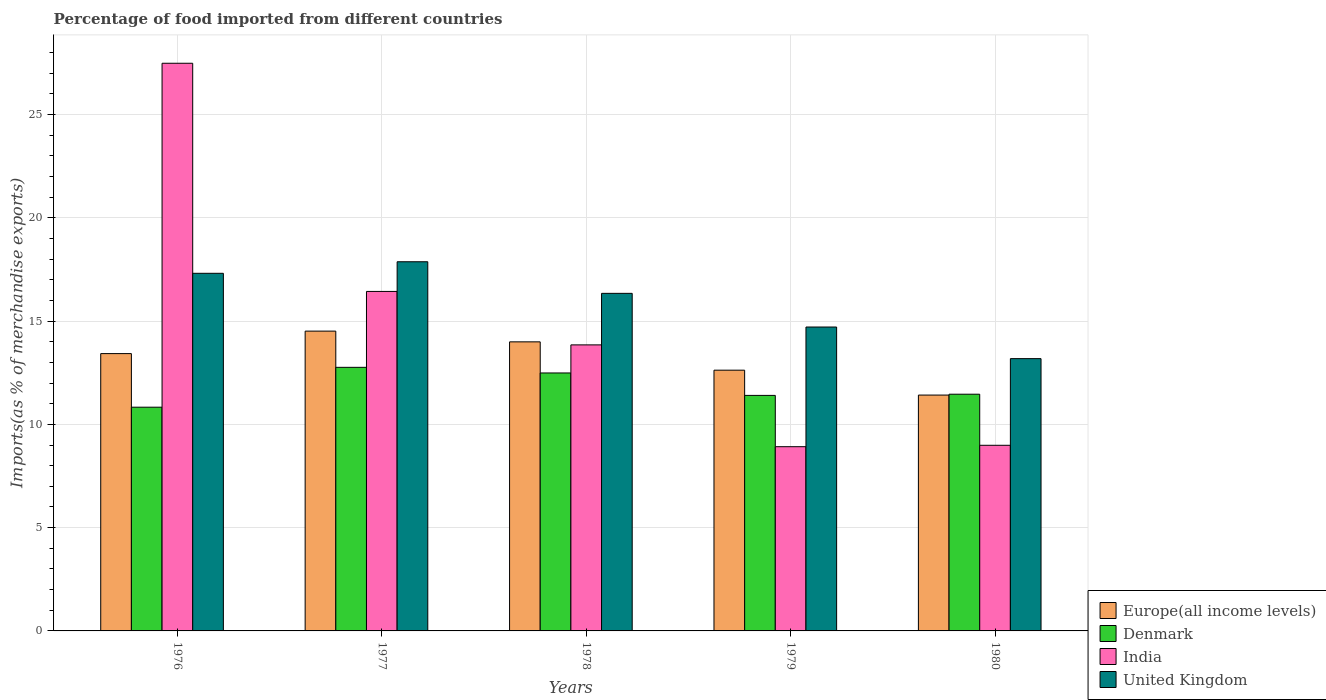How many groups of bars are there?
Provide a short and direct response. 5. Are the number of bars per tick equal to the number of legend labels?
Your answer should be very brief. Yes. How many bars are there on the 5th tick from the left?
Your answer should be compact. 4. How many bars are there on the 2nd tick from the right?
Give a very brief answer. 4. What is the label of the 2nd group of bars from the left?
Give a very brief answer. 1977. In how many cases, is the number of bars for a given year not equal to the number of legend labels?
Make the answer very short. 0. What is the percentage of imports to different countries in Denmark in 1978?
Provide a short and direct response. 12.49. Across all years, what is the maximum percentage of imports to different countries in Europe(all income levels)?
Your answer should be very brief. 14.51. Across all years, what is the minimum percentage of imports to different countries in Denmark?
Ensure brevity in your answer.  10.83. In which year was the percentage of imports to different countries in India maximum?
Give a very brief answer. 1976. What is the total percentage of imports to different countries in Europe(all income levels) in the graph?
Your response must be concise. 65.97. What is the difference between the percentage of imports to different countries in India in 1976 and that in 1978?
Your response must be concise. 13.63. What is the difference between the percentage of imports to different countries in Denmark in 1977 and the percentage of imports to different countries in United Kingdom in 1978?
Your answer should be compact. -3.58. What is the average percentage of imports to different countries in Denmark per year?
Ensure brevity in your answer.  11.79. In the year 1980, what is the difference between the percentage of imports to different countries in United Kingdom and percentage of imports to different countries in Europe(all income levels)?
Your answer should be very brief. 1.76. In how many years, is the percentage of imports to different countries in India greater than 10 %?
Your response must be concise. 3. What is the ratio of the percentage of imports to different countries in Europe(all income levels) in 1978 to that in 1979?
Your answer should be very brief. 1.11. Is the percentage of imports to different countries in Denmark in 1978 less than that in 1980?
Provide a short and direct response. No. What is the difference between the highest and the second highest percentage of imports to different countries in Denmark?
Give a very brief answer. 0.27. What is the difference between the highest and the lowest percentage of imports to different countries in Denmark?
Offer a very short reply. 1.93. In how many years, is the percentage of imports to different countries in Europe(all income levels) greater than the average percentage of imports to different countries in Europe(all income levels) taken over all years?
Provide a short and direct response. 3. Is the sum of the percentage of imports to different countries in Europe(all income levels) in 1977 and 1980 greater than the maximum percentage of imports to different countries in India across all years?
Offer a terse response. No. What does the 2nd bar from the right in 1978 represents?
Give a very brief answer. India. Is it the case that in every year, the sum of the percentage of imports to different countries in India and percentage of imports to different countries in Europe(all income levels) is greater than the percentage of imports to different countries in United Kingdom?
Your answer should be very brief. Yes. How many bars are there?
Ensure brevity in your answer.  20. Are all the bars in the graph horizontal?
Ensure brevity in your answer.  No. How many years are there in the graph?
Offer a very short reply. 5. Does the graph contain any zero values?
Provide a short and direct response. No. Does the graph contain grids?
Provide a succinct answer. Yes. Where does the legend appear in the graph?
Offer a terse response. Bottom right. How are the legend labels stacked?
Your response must be concise. Vertical. What is the title of the graph?
Provide a succinct answer. Percentage of food imported from different countries. What is the label or title of the Y-axis?
Offer a very short reply. Imports(as % of merchandise exports). What is the Imports(as % of merchandise exports) in Europe(all income levels) in 1976?
Your answer should be compact. 13.42. What is the Imports(as % of merchandise exports) in Denmark in 1976?
Ensure brevity in your answer.  10.83. What is the Imports(as % of merchandise exports) of India in 1976?
Provide a succinct answer. 27.48. What is the Imports(as % of merchandise exports) in United Kingdom in 1976?
Your answer should be very brief. 17.31. What is the Imports(as % of merchandise exports) in Europe(all income levels) in 1977?
Ensure brevity in your answer.  14.51. What is the Imports(as % of merchandise exports) in Denmark in 1977?
Provide a short and direct response. 12.76. What is the Imports(as % of merchandise exports) in India in 1977?
Make the answer very short. 16.43. What is the Imports(as % of merchandise exports) of United Kingdom in 1977?
Your response must be concise. 17.87. What is the Imports(as % of merchandise exports) in Europe(all income levels) in 1978?
Offer a terse response. 13.99. What is the Imports(as % of merchandise exports) of Denmark in 1978?
Your response must be concise. 12.49. What is the Imports(as % of merchandise exports) of India in 1978?
Your response must be concise. 13.85. What is the Imports(as % of merchandise exports) of United Kingdom in 1978?
Your answer should be very brief. 16.34. What is the Imports(as % of merchandise exports) in Europe(all income levels) in 1979?
Provide a succinct answer. 12.62. What is the Imports(as % of merchandise exports) of Denmark in 1979?
Your answer should be compact. 11.4. What is the Imports(as % of merchandise exports) in India in 1979?
Offer a very short reply. 8.92. What is the Imports(as % of merchandise exports) of United Kingdom in 1979?
Offer a terse response. 14.71. What is the Imports(as % of merchandise exports) of Europe(all income levels) in 1980?
Offer a terse response. 11.42. What is the Imports(as % of merchandise exports) in Denmark in 1980?
Offer a very short reply. 11.46. What is the Imports(as % of merchandise exports) of India in 1980?
Ensure brevity in your answer.  8.99. What is the Imports(as % of merchandise exports) of United Kingdom in 1980?
Keep it short and to the point. 13.18. Across all years, what is the maximum Imports(as % of merchandise exports) in Europe(all income levels)?
Keep it short and to the point. 14.51. Across all years, what is the maximum Imports(as % of merchandise exports) in Denmark?
Provide a succinct answer. 12.76. Across all years, what is the maximum Imports(as % of merchandise exports) of India?
Your answer should be compact. 27.48. Across all years, what is the maximum Imports(as % of merchandise exports) of United Kingdom?
Provide a short and direct response. 17.87. Across all years, what is the minimum Imports(as % of merchandise exports) of Europe(all income levels)?
Provide a short and direct response. 11.42. Across all years, what is the minimum Imports(as % of merchandise exports) in Denmark?
Offer a very short reply. 10.83. Across all years, what is the minimum Imports(as % of merchandise exports) of India?
Provide a succinct answer. 8.92. Across all years, what is the minimum Imports(as % of merchandise exports) in United Kingdom?
Make the answer very short. 13.18. What is the total Imports(as % of merchandise exports) in Europe(all income levels) in the graph?
Provide a succinct answer. 65.97. What is the total Imports(as % of merchandise exports) in Denmark in the graph?
Your response must be concise. 58.94. What is the total Imports(as % of merchandise exports) in India in the graph?
Keep it short and to the point. 75.67. What is the total Imports(as % of merchandise exports) in United Kingdom in the graph?
Your answer should be compact. 79.42. What is the difference between the Imports(as % of merchandise exports) in Europe(all income levels) in 1976 and that in 1977?
Offer a terse response. -1.09. What is the difference between the Imports(as % of merchandise exports) in Denmark in 1976 and that in 1977?
Offer a terse response. -1.93. What is the difference between the Imports(as % of merchandise exports) in India in 1976 and that in 1977?
Offer a terse response. 11.05. What is the difference between the Imports(as % of merchandise exports) of United Kingdom in 1976 and that in 1977?
Provide a succinct answer. -0.56. What is the difference between the Imports(as % of merchandise exports) of Europe(all income levels) in 1976 and that in 1978?
Your response must be concise. -0.57. What is the difference between the Imports(as % of merchandise exports) in Denmark in 1976 and that in 1978?
Keep it short and to the point. -1.66. What is the difference between the Imports(as % of merchandise exports) of India in 1976 and that in 1978?
Give a very brief answer. 13.63. What is the difference between the Imports(as % of merchandise exports) of United Kingdom in 1976 and that in 1978?
Keep it short and to the point. 0.97. What is the difference between the Imports(as % of merchandise exports) in Europe(all income levels) in 1976 and that in 1979?
Your answer should be very brief. 0.8. What is the difference between the Imports(as % of merchandise exports) of Denmark in 1976 and that in 1979?
Provide a short and direct response. -0.57. What is the difference between the Imports(as % of merchandise exports) in India in 1976 and that in 1979?
Offer a very short reply. 18.56. What is the difference between the Imports(as % of merchandise exports) of United Kingdom in 1976 and that in 1979?
Your answer should be compact. 2.6. What is the difference between the Imports(as % of merchandise exports) of Europe(all income levels) in 1976 and that in 1980?
Make the answer very short. 2.01. What is the difference between the Imports(as % of merchandise exports) in Denmark in 1976 and that in 1980?
Provide a short and direct response. -0.63. What is the difference between the Imports(as % of merchandise exports) of India in 1976 and that in 1980?
Give a very brief answer. 18.49. What is the difference between the Imports(as % of merchandise exports) of United Kingdom in 1976 and that in 1980?
Your answer should be compact. 4.13. What is the difference between the Imports(as % of merchandise exports) of Europe(all income levels) in 1977 and that in 1978?
Keep it short and to the point. 0.52. What is the difference between the Imports(as % of merchandise exports) of Denmark in 1977 and that in 1978?
Offer a terse response. 0.27. What is the difference between the Imports(as % of merchandise exports) in India in 1977 and that in 1978?
Offer a terse response. 2.59. What is the difference between the Imports(as % of merchandise exports) in United Kingdom in 1977 and that in 1978?
Provide a short and direct response. 1.53. What is the difference between the Imports(as % of merchandise exports) in Europe(all income levels) in 1977 and that in 1979?
Your answer should be very brief. 1.89. What is the difference between the Imports(as % of merchandise exports) in Denmark in 1977 and that in 1979?
Make the answer very short. 1.36. What is the difference between the Imports(as % of merchandise exports) in India in 1977 and that in 1979?
Your answer should be compact. 7.52. What is the difference between the Imports(as % of merchandise exports) in United Kingdom in 1977 and that in 1979?
Make the answer very short. 3.16. What is the difference between the Imports(as % of merchandise exports) in Europe(all income levels) in 1977 and that in 1980?
Make the answer very short. 3.1. What is the difference between the Imports(as % of merchandise exports) of Denmark in 1977 and that in 1980?
Provide a succinct answer. 1.3. What is the difference between the Imports(as % of merchandise exports) of India in 1977 and that in 1980?
Keep it short and to the point. 7.45. What is the difference between the Imports(as % of merchandise exports) of United Kingdom in 1977 and that in 1980?
Your response must be concise. 4.69. What is the difference between the Imports(as % of merchandise exports) of Europe(all income levels) in 1978 and that in 1979?
Provide a short and direct response. 1.37. What is the difference between the Imports(as % of merchandise exports) in Denmark in 1978 and that in 1979?
Keep it short and to the point. 1.09. What is the difference between the Imports(as % of merchandise exports) of India in 1978 and that in 1979?
Provide a short and direct response. 4.93. What is the difference between the Imports(as % of merchandise exports) in United Kingdom in 1978 and that in 1979?
Make the answer very short. 1.63. What is the difference between the Imports(as % of merchandise exports) in Europe(all income levels) in 1978 and that in 1980?
Provide a succinct answer. 2.58. What is the difference between the Imports(as % of merchandise exports) in Denmark in 1978 and that in 1980?
Offer a terse response. 1.03. What is the difference between the Imports(as % of merchandise exports) in India in 1978 and that in 1980?
Offer a very short reply. 4.86. What is the difference between the Imports(as % of merchandise exports) in United Kingdom in 1978 and that in 1980?
Provide a short and direct response. 3.16. What is the difference between the Imports(as % of merchandise exports) of Europe(all income levels) in 1979 and that in 1980?
Make the answer very short. 1.21. What is the difference between the Imports(as % of merchandise exports) of Denmark in 1979 and that in 1980?
Your response must be concise. -0.06. What is the difference between the Imports(as % of merchandise exports) in India in 1979 and that in 1980?
Give a very brief answer. -0.07. What is the difference between the Imports(as % of merchandise exports) of United Kingdom in 1979 and that in 1980?
Provide a succinct answer. 1.53. What is the difference between the Imports(as % of merchandise exports) of Europe(all income levels) in 1976 and the Imports(as % of merchandise exports) of Denmark in 1977?
Your response must be concise. 0.66. What is the difference between the Imports(as % of merchandise exports) of Europe(all income levels) in 1976 and the Imports(as % of merchandise exports) of India in 1977?
Give a very brief answer. -3.01. What is the difference between the Imports(as % of merchandise exports) of Europe(all income levels) in 1976 and the Imports(as % of merchandise exports) of United Kingdom in 1977?
Make the answer very short. -4.45. What is the difference between the Imports(as % of merchandise exports) in Denmark in 1976 and the Imports(as % of merchandise exports) in India in 1977?
Provide a short and direct response. -5.6. What is the difference between the Imports(as % of merchandise exports) of Denmark in 1976 and the Imports(as % of merchandise exports) of United Kingdom in 1977?
Ensure brevity in your answer.  -7.04. What is the difference between the Imports(as % of merchandise exports) of India in 1976 and the Imports(as % of merchandise exports) of United Kingdom in 1977?
Make the answer very short. 9.61. What is the difference between the Imports(as % of merchandise exports) in Europe(all income levels) in 1976 and the Imports(as % of merchandise exports) in Denmark in 1978?
Provide a succinct answer. 0.94. What is the difference between the Imports(as % of merchandise exports) in Europe(all income levels) in 1976 and the Imports(as % of merchandise exports) in India in 1978?
Offer a terse response. -0.42. What is the difference between the Imports(as % of merchandise exports) in Europe(all income levels) in 1976 and the Imports(as % of merchandise exports) in United Kingdom in 1978?
Give a very brief answer. -2.92. What is the difference between the Imports(as % of merchandise exports) in Denmark in 1976 and the Imports(as % of merchandise exports) in India in 1978?
Make the answer very short. -3.02. What is the difference between the Imports(as % of merchandise exports) in Denmark in 1976 and the Imports(as % of merchandise exports) in United Kingdom in 1978?
Offer a terse response. -5.51. What is the difference between the Imports(as % of merchandise exports) in India in 1976 and the Imports(as % of merchandise exports) in United Kingdom in 1978?
Ensure brevity in your answer.  11.14. What is the difference between the Imports(as % of merchandise exports) in Europe(all income levels) in 1976 and the Imports(as % of merchandise exports) in Denmark in 1979?
Give a very brief answer. 2.02. What is the difference between the Imports(as % of merchandise exports) of Europe(all income levels) in 1976 and the Imports(as % of merchandise exports) of India in 1979?
Your answer should be compact. 4.51. What is the difference between the Imports(as % of merchandise exports) of Europe(all income levels) in 1976 and the Imports(as % of merchandise exports) of United Kingdom in 1979?
Offer a very short reply. -1.29. What is the difference between the Imports(as % of merchandise exports) of Denmark in 1976 and the Imports(as % of merchandise exports) of India in 1979?
Your answer should be compact. 1.91. What is the difference between the Imports(as % of merchandise exports) of Denmark in 1976 and the Imports(as % of merchandise exports) of United Kingdom in 1979?
Keep it short and to the point. -3.88. What is the difference between the Imports(as % of merchandise exports) of India in 1976 and the Imports(as % of merchandise exports) of United Kingdom in 1979?
Ensure brevity in your answer.  12.77. What is the difference between the Imports(as % of merchandise exports) in Europe(all income levels) in 1976 and the Imports(as % of merchandise exports) in Denmark in 1980?
Your response must be concise. 1.97. What is the difference between the Imports(as % of merchandise exports) of Europe(all income levels) in 1976 and the Imports(as % of merchandise exports) of India in 1980?
Offer a very short reply. 4.44. What is the difference between the Imports(as % of merchandise exports) of Europe(all income levels) in 1976 and the Imports(as % of merchandise exports) of United Kingdom in 1980?
Offer a very short reply. 0.24. What is the difference between the Imports(as % of merchandise exports) of Denmark in 1976 and the Imports(as % of merchandise exports) of India in 1980?
Your response must be concise. 1.84. What is the difference between the Imports(as % of merchandise exports) of Denmark in 1976 and the Imports(as % of merchandise exports) of United Kingdom in 1980?
Your answer should be very brief. -2.35. What is the difference between the Imports(as % of merchandise exports) of India in 1976 and the Imports(as % of merchandise exports) of United Kingdom in 1980?
Offer a very short reply. 14.3. What is the difference between the Imports(as % of merchandise exports) of Europe(all income levels) in 1977 and the Imports(as % of merchandise exports) of Denmark in 1978?
Ensure brevity in your answer.  2.03. What is the difference between the Imports(as % of merchandise exports) in Europe(all income levels) in 1977 and the Imports(as % of merchandise exports) in India in 1978?
Provide a succinct answer. 0.67. What is the difference between the Imports(as % of merchandise exports) in Europe(all income levels) in 1977 and the Imports(as % of merchandise exports) in United Kingdom in 1978?
Your response must be concise. -1.83. What is the difference between the Imports(as % of merchandise exports) in Denmark in 1977 and the Imports(as % of merchandise exports) in India in 1978?
Provide a succinct answer. -1.09. What is the difference between the Imports(as % of merchandise exports) of Denmark in 1977 and the Imports(as % of merchandise exports) of United Kingdom in 1978?
Provide a short and direct response. -3.58. What is the difference between the Imports(as % of merchandise exports) in India in 1977 and the Imports(as % of merchandise exports) in United Kingdom in 1978?
Ensure brevity in your answer.  0.09. What is the difference between the Imports(as % of merchandise exports) in Europe(all income levels) in 1977 and the Imports(as % of merchandise exports) in Denmark in 1979?
Your response must be concise. 3.11. What is the difference between the Imports(as % of merchandise exports) in Europe(all income levels) in 1977 and the Imports(as % of merchandise exports) in India in 1979?
Make the answer very short. 5.59. What is the difference between the Imports(as % of merchandise exports) of Europe(all income levels) in 1977 and the Imports(as % of merchandise exports) of United Kingdom in 1979?
Your response must be concise. -0.2. What is the difference between the Imports(as % of merchandise exports) of Denmark in 1977 and the Imports(as % of merchandise exports) of India in 1979?
Offer a very short reply. 3.84. What is the difference between the Imports(as % of merchandise exports) in Denmark in 1977 and the Imports(as % of merchandise exports) in United Kingdom in 1979?
Offer a terse response. -1.95. What is the difference between the Imports(as % of merchandise exports) of India in 1977 and the Imports(as % of merchandise exports) of United Kingdom in 1979?
Offer a terse response. 1.72. What is the difference between the Imports(as % of merchandise exports) in Europe(all income levels) in 1977 and the Imports(as % of merchandise exports) in Denmark in 1980?
Your answer should be compact. 3.05. What is the difference between the Imports(as % of merchandise exports) in Europe(all income levels) in 1977 and the Imports(as % of merchandise exports) in India in 1980?
Make the answer very short. 5.53. What is the difference between the Imports(as % of merchandise exports) in Europe(all income levels) in 1977 and the Imports(as % of merchandise exports) in United Kingdom in 1980?
Provide a succinct answer. 1.33. What is the difference between the Imports(as % of merchandise exports) in Denmark in 1977 and the Imports(as % of merchandise exports) in India in 1980?
Ensure brevity in your answer.  3.77. What is the difference between the Imports(as % of merchandise exports) of Denmark in 1977 and the Imports(as % of merchandise exports) of United Kingdom in 1980?
Provide a succinct answer. -0.42. What is the difference between the Imports(as % of merchandise exports) of India in 1977 and the Imports(as % of merchandise exports) of United Kingdom in 1980?
Ensure brevity in your answer.  3.25. What is the difference between the Imports(as % of merchandise exports) of Europe(all income levels) in 1978 and the Imports(as % of merchandise exports) of Denmark in 1979?
Make the answer very short. 2.59. What is the difference between the Imports(as % of merchandise exports) in Europe(all income levels) in 1978 and the Imports(as % of merchandise exports) in India in 1979?
Give a very brief answer. 5.08. What is the difference between the Imports(as % of merchandise exports) of Europe(all income levels) in 1978 and the Imports(as % of merchandise exports) of United Kingdom in 1979?
Your answer should be very brief. -0.72. What is the difference between the Imports(as % of merchandise exports) of Denmark in 1978 and the Imports(as % of merchandise exports) of India in 1979?
Your answer should be very brief. 3.57. What is the difference between the Imports(as % of merchandise exports) in Denmark in 1978 and the Imports(as % of merchandise exports) in United Kingdom in 1979?
Ensure brevity in your answer.  -2.22. What is the difference between the Imports(as % of merchandise exports) of India in 1978 and the Imports(as % of merchandise exports) of United Kingdom in 1979?
Give a very brief answer. -0.86. What is the difference between the Imports(as % of merchandise exports) in Europe(all income levels) in 1978 and the Imports(as % of merchandise exports) in Denmark in 1980?
Ensure brevity in your answer.  2.53. What is the difference between the Imports(as % of merchandise exports) of Europe(all income levels) in 1978 and the Imports(as % of merchandise exports) of India in 1980?
Your response must be concise. 5.01. What is the difference between the Imports(as % of merchandise exports) of Europe(all income levels) in 1978 and the Imports(as % of merchandise exports) of United Kingdom in 1980?
Give a very brief answer. 0.81. What is the difference between the Imports(as % of merchandise exports) of Denmark in 1978 and the Imports(as % of merchandise exports) of India in 1980?
Offer a very short reply. 3.5. What is the difference between the Imports(as % of merchandise exports) in Denmark in 1978 and the Imports(as % of merchandise exports) in United Kingdom in 1980?
Ensure brevity in your answer.  -0.69. What is the difference between the Imports(as % of merchandise exports) in India in 1978 and the Imports(as % of merchandise exports) in United Kingdom in 1980?
Offer a terse response. 0.67. What is the difference between the Imports(as % of merchandise exports) in Europe(all income levels) in 1979 and the Imports(as % of merchandise exports) in Denmark in 1980?
Your response must be concise. 1.16. What is the difference between the Imports(as % of merchandise exports) of Europe(all income levels) in 1979 and the Imports(as % of merchandise exports) of India in 1980?
Keep it short and to the point. 3.64. What is the difference between the Imports(as % of merchandise exports) of Europe(all income levels) in 1979 and the Imports(as % of merchandise exports) of United Kingdom in 1980?
Give a very brief answer. -0.56. What is the difference between the Imports(as % of merchandise exports) in Denmark in 1979 and the Imports(as % of merchandise exports) in India in 1980?
Keep it short and to the point. 2.42. What is the difference between the Imports(as % of merchandise exports) of Denmark in 1979 and the Imports(as % of merchandise exports) of United Kingdom in 1980?
Your answer should be compact. -1.78. What is the difference between the Imports(as % of merchandise exports) in India in 1979 and the Imports(as % of merchandise exports) in United Kingdom in 1980?
Your response must be concise. -4.26. What is the average Imports(as % of merchandise exports) of Europe(all income levels) per year?
Provide a succinct answer. 13.19. What is the average Imports(as % of merchandise exports) of Denmark per year?
Your answer should be very brief. 11.79. What is the average Imports(as % of merchandise exports) of India per year?
Provide a short and direct response. 15.13. What is the average Imports(as % of merchandise exports) in United Kingdom per year?
Give a very brief answer. 15.88. In the year 1976, what is the difference between the Imports(as % of merchandise exports) of Europe(all income levels) and Imports(as % of merchandise exports) of Denmark?
Keep it short and to the point. 2.59. In the year 1976, what is the difference between the Imports(as % of merchandise exports) in Europe(all income levels) and Imports(as % of merchandise exports) in India?
Offer a terse response. -14.06. In the year 1976, what is the difference between the Imports(as % of merchandise exports) of Europe(all income levels) and Imports(as % of merchandise exports) of United Kingdom?
Offer a terse response. -3.89. In the year 1976, what is the difference between the Imports(as % of merchandise exports) in Denmark and Imports(as % of merchandise exports) in India?
Make the answer very short. -16.65. In the year 1976, what is the difference between the Imports(as % of merchandise exports) of Denmark and Imports(as % of merchandise exports) of United Kingdom?
Provide a short and direct response. -6.48. In the year 1976, what is the difference between the Imports(as % of merchandise exports) in India and Imports(as % of merchandise exports) in United Kingdom?
Offer a terse response. 10.17. In the year 1977, what is the difference between the Imports(as % of merchandise exports) of Europe(all income levels) and Imports(as % of merchandise exports) of Denmark?
Offer a very short reply. 1.75. In the year 1977, what is the difference between the Imports(as % of merchandise exports) in Europe(all income levels) and Imports(as % of merchandise exports) in India?
Keep it short and to the point. -1.92. In the year 1977, what is the difference between the Imports(as % of merchandise exports) in Europe(all income levels) and Imports(as % of merchandise exports) in United Kingdom?
Keep it short and to the point. -3.36. In the year 1977, what is the difference between the Imports(as % of merchandise exports) in Denmark and Imports(as % of merchandise exports) in India?
Your response must be concise. -3.67. In the year 1977, what is the difference between the Imports(as % of merchandise exports) of Denmark and Imports(as % of merchandise exports) of United Kingdom?
Keep it short and to the point. -5.11. In the year 1977, what is the difference between the Imports(as % of merchandise exports) in India and Imports(as % of merchandise exports) in United Kingdom?
Make the answer very short. -1.44. In the year 1978, what is the difference between the Imports(as % of merchandise exports) in Europe(all income levels) and Imports(as % of merchandise exports) in Denmark?
Offer a terse response. 1.51. In the year 1978, what is the difference between the Imports(as % of merchandise exports) of Europe(all income levels) and Imports(as % of merchandise exports) of India?
Your answer should be very brief. 0.15. In the year 1978, what is the difference between the Imports(as % of merchandise exports) of Europe(all income levels) and Imports(as % of merchandise exports) of United Kingdom?
Give a very brief answer. -2.35. In the year 1978, what is the difference between the Imports(as % of merchandise exports) in Denmark and Imports(as % of merchandise exports) in India?
Provide a short and direct response. -1.36. In the year 1978, what is the difference between the Imports(as % of merchandise exports) in Denmark and Imports(as % of merchandise exports) in United Kingdom?
Make the answer very short. -3.85. In the year 1978, what is the difference between the Imports(as % of merchandise exports) in India and Imports(as % of merchandise exports) in United Kingdom?
Offer a very short reply. -2.5. In the year 1979, what is the difference between the Imports(as % of merchandise exports) of Europe(all income levels) and Imports(as % of merchandise exports) of Denmark?
Provide a short and direct response. 1.22. In the year 1979, what is the difference between the Imports(as % of merchandise exports) in Europe(all income levels) and Imports(as % of merchandise exports) in India?
Your answer should be very brief. 3.7. In the year 1979, what is the difference between the Imports(as % of merchandise exports) of Europe(all income levels) and Imports(as % of merchandise exports) of United Kingdom?
Ensure brevity in your answer.  -2.09. In the year 1979, what is the difference between the Imports(as % of merchandise exports) of Denmark and Imports(as % of merchandise exports) of India?
Provide a succinct answer. 2.48. In the year 1979, what is the difference between the Imports(as % of merchandise exports) in Denmark and Imports(as % of merchandise exports) in United Kingdom?
Give a very brief answer. -3.31. In the year 1979, what is the difference between the Imports(as % of merchandise exports) in India and Imports(as % of merchandise exports) in United Kingdom?
Provide a succinct answer. -5.79. In the year 1980, what is the difference between the Imports(as % of merchandise exports) of Europe(all income levels) and Imports(as % of merchandise exports) of Denmark?
Your response must be concise. -0.04. In the year 1980, what is the difference between the Imports(as % of merchandise exports) of Europe(all income levels) and Imports(as % of merchandise exports) of India?
Offer a terse response. 2.43. In the year 1980, what is the difference between the Imports(as % of merchandise exports) in Europe(all income levels) and Imports(as % of merchandise exports) in United Kingdom?
Ensure brevity in your answer.  -1.76. In the year 1980, what is the difference between the Imports(as % of merchandise exports) in Denmark and Imports(as % of merchandise exports) in India?
Your answer should be very brief. 2.47. In the year 1980, what is the difference between the Imports(as % of merchandise exports) of Denmark and Imports(as % of merchandise exports) of United Kingdom?
Your answer should be compact. -1.72. In the year 1980, what is the difference between the Imports(as % of merchandise exports) of India and Imports(as % of merchandise exports) of United Kingdom?
Your response must be concise. -4.2. What is the ratio of the Imports(as % of merchandise exports) in Europe(all income levels) in 1976 to that in 1977?
Provide a succinct answer. 0.93. What is the ratio of the Imports(as % of merchandise exports) of Denmark in 1976 to that in 1977?
Give a very brief answer. 0.85. What is the ratio of the Imports(as % of merchandise exports) of India in 1976 to that in 1977?
Your answer should be compact. 1.67. What is the ratio of the Imports(as % of merchandise exports) of United Kingdom in 1976 to that in 1977?
Your response must be concise. 0.97. What is the ratio of the Imports(as % of merchandise exports) of Europe(all income levels) in 1976 to that in 1978?
Keep it short and to the point. 0.96. What is the ratio of the Imports(as % of merchandise exports) of Denmark in 1976 to that in 1978?
Your answer should be very brief. 0.87. What is the ratio of the Imports(as % of merchandise exports) of India in 1976 to that in 1978?
Keep it short and to the point. 1.98. What is the ratio of the Imports(as % of merchandise exports) in United Kingdom in 1976 to that in 1978?
Your response must be concise. 1.06. What is the ratio of the Imports(as % of merchandise exports) of Europe(all income levels) in 1976 to that in 1979?
Offer a terse response. 1.06. What is the ratio of the Imports(as % of merchandise exports) in Denmark in 1976 to that in 1979?
Your answer should be compact. 0.95. What is the ratio of the Imports(as % of merchandise exports) in India in 1976 to that in 1979?
Ensure brevity in your answer.  3.08. What is the ratio of the Imports(as % of merchandise exports) in United Kingdom in 1976 to that in 1979?
Your response must be concise. 1.18. What is the ratio of the Imports(as % of merchandise exports) of Europe(all income levels) in 1976 to that in 1980?
Keep it short and to the point. 1.18. What is the ratio of the Imports(as % of merchandise exports) in Denmark in 1976 to that in 1980?
Provide a short and direct response. 0.95. What is the ratio of the Imports(as % of merchandise exports) of India in 1976 to that in 1980?
Offer a terse response. 3.06. What is the ratio of the Imports(as % of merchandise exports) in United Kingdom in 1976 to that in 1980?
Keep it short and to the point. 1.31. What is the ratio of the Imports(as % of merchandise exports) of Europe(all income levels) in 1977 to that in 1978?
Offer a very short reply. 1.04. What is the ratio of the Imports(as % of merchandise exports) of Denmark in 1977 to that in 1978?
Offer a terse response. 1.02. What is the ratio of the Imports(as % of merchandise exports) in India in 1977 to that in 1978?
Give a very brief answer. 1.19. What is the ratio of the Imports(as % of merchandise exports) in United Kingdom in 1977 to that in 1978?
Provide a succinct answer. 1.09. What is the ratio of the Imports(as % of merchandise exports) of Europe(all income levels) in 1977 to that in 1979?
Ensure brevity in your answer.  1.15. What is the ratio of the Imports(as % of merchandise exports) in Denmark in 1977 to that in 1979?
Ensure brevity in your answer.  1.12. What is the ratio of the Imports(as % of merchandise exports) in India in 1977 to that in 1979?
Offer a very short reply. 1.84. What is the ratio of the Imports(as % of merchandise exports) in United Kingdom in 1977 to that in 1979?
Your answer should be very brief. 1.21. What is the ratio of the Imports(as % of merchandise exports) in Europe(all income levels) in 1977 to that in 1980?
Keep it short and to the point. 1.27. What is the ratio of the Imports(as % of merchandise exports) of Denmark in 1977 to that in 1980?
Provide a succinct answer. 1.11. What is the ratio of the Imports(as % of merchandise exports) of India in 1977 to that in 1980?
Your answer should be compact. 1.83. What is the ratio of the Imports(as % of merchandise exports) in United Kingdom in 1977 to that in 1980?
Provide a succinct answer. 1.36. What is the ratio of the Imports(as % of merchandise exports) in Europe(all income levels) in 1978 to that in 1979?
Make the answer very short. 1.11. What is the ratio of the Imports(as % of merchandise exports) of Denmark in 1978 to that in 1979?
Make the answer very short. 1.1. What is the ratio of the Imports(as % of merchandise exports) in India in 1978 to that in 1979?
Keep it short and to the point. 1.55. What is the ratio of the Imports(as % of merchandise exports) of United Kingdom in 1978 to that in 1979?
Make the answer very short. 1.11. What is the ratio of the Imports(as % of merchandise exports) of Europe(all income levels) in 1978 to that in 1980?
Provide a succinct answer. 1.23. What is the ratio of the Imports(as % of merchandise exports) of Denmark in 1978 to that in 1980?
Keep it short and to the point. 1.09. What is the ratio of the Imports(as % of merchandise exports) of India in 1978 to that in 1980?
Make the answer very short. 1.54. What is the ratio of the Imports(as % of merchandise exports) of United Kingdom in 1978 to that in 1980?
Provide a succinct answer. 1.24. What is the ratio of the Imports(as % of merchandise exports) in Europe(all income levels) in 1979 to that in 1980?
Your answer should be compact. 1.11. What is the ratio of the Imports(as % of merchandise exports) in Denmark in 1979 to that in 1980?
Provide a short and direct response. 0.99. What is the ratio of the Imports(as % of merchandise exports) of India in 1979 to that in 1980?
Offer a very short reply. 0.99. What is the ratio of the Imports(as % of merchandise exports) in United Kingdom in 1979 to that in 1980?
Give a very brief answer. 1.12. What is the difference between the highest and the second highest Imports(as % of merchandise exports) in Europe(all income levels)?
Your answer should be compact. 0.52. What is the difference between the highest and the second highest Imports(as % of merchandise exports) in Denmark?
Offer a terse response. 0.27. What is the difference between the highest and the second highest Imports(as % of merchandise exports) of India?
Make the answer very short. 11.05. What is the difference between the highest and the second highest Imports(as % of merchandise exports) in United Kingdom?
Offer a terse response. 0.56. What is the difference between the highest and the lowest Imports(as % of merchandise exports) of Europe(all income levels)?
Your answer should be compact. 3.1. What is the difference between the highest and the lowest Imports(as % of merchandise exports) in Denmark?
Make the answer very short. 1.93. What is the difference between the highest and the lowest Imports(as % of merchandise exports) in India?
Ensure brevity in your answer.  18.56. What is the difference between the highest and the lowest Imports(as % of merchandise exports) of United Kingdom?
Your answer should be very brief. 4.69. 